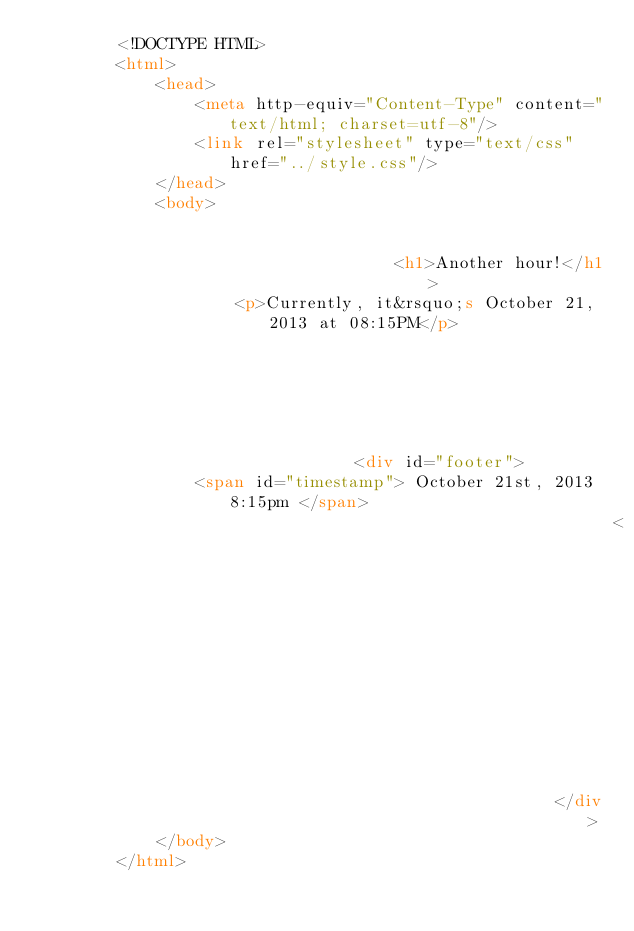<code> <loc_0><loc_0><loc_500><loc_500><_HTML_>        <!DOCTYPE HTML>
        <html>
            <head>
                <meta http-equiv="Content-Type" content="text/html; charset=utf-8"/>
                <link rel="stylesheet" type="text/css" href="../style.css"/>
            </head>
            <body>
                
                
                                    <h1>Another hour!</h1>
                    <p>Currently, it&rsquo;s October 21, 2013 at 08:15PM</p>
                
                
                
                
                
                
                                <div id="footer">
                <span id="timestamp"> October 21st, 2013 8:15pm </span>
                                                          <span class="tag">IFTTT</span>
                                                    </div>
            </body>
        </html>

        </code> 